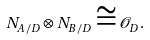<formula> <loc_0><loc_0><loc_500><loc_500>N _ { A / D } \otimes N _ { B / D } \cong \mathcal { O } _ { D } .</formula> 